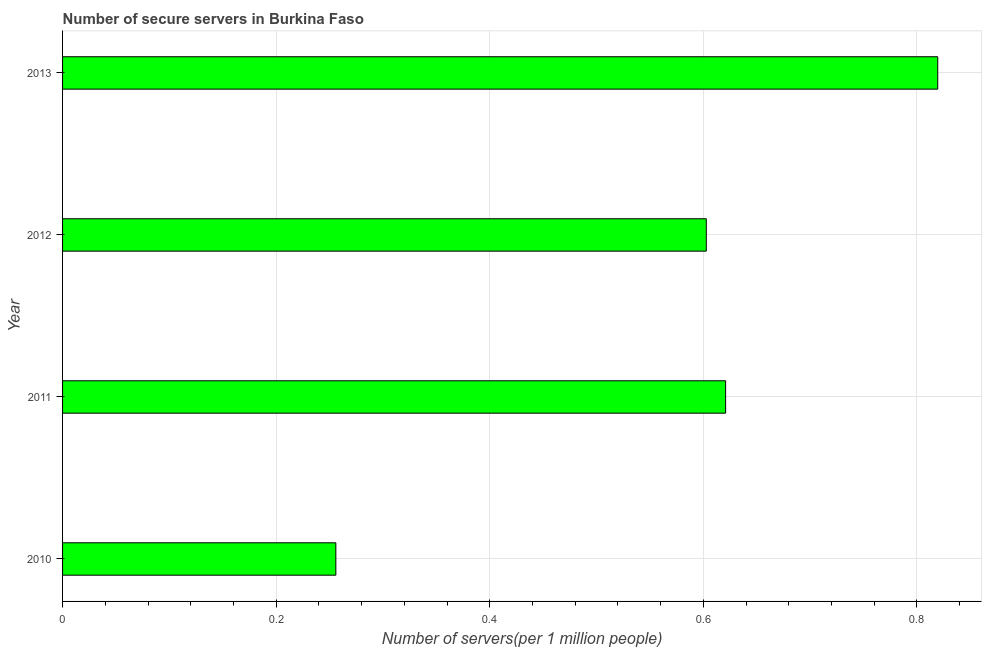Does the graph contain grids?
Give a very brief answer. Yes. What is the title of the graph?
Make the answer very short. Number of secure servers in Burkina Faso. What is the label or title of the X-axis?
Make the answer very short. Number of servers(per 1 million people). What is the label or title of the Y-axis?
Your answer should be compact. Year. What is the number of secure internet servers in 2013?
Your response must be concise. 0.82. Across all years, what is the maximum number of secure internet servers?
Offer a very short reply. 0.82. Across all years, what is the minimum number of secure internet servers?
Your answer should be compact. 0.26. What is the sum of the number of secure internet servers?
Provide a succinct answer. 2.3. What is the difference between the number of secure internet servers in 2010 and 2011?
Your response must be concise. -0.36. What is the average number of secure internet servers per year?
Offer a terse response. 0.57. What is the median number of secure internet servers?
Provide a short and direct response. 0.61. In how many years, is the number of secure internet servers greater than 0.28 ?
Ensure brevity in your answer.  3. Do a majority of the years between 2011 and 2012 (inclusive) have number of secure internet servers greater than 0.2 ?
Keep it short and to the point. Yes. What is the ratio of the number of secure internet servers in 2010 to that in 2012?
Give a very brief answer. 0.42. Is the number of secure internet servers in 2011 less than that in 2013?
Make the answer very short. Yes. Is the difference between the number of secure internet servers in 2010 and 2012 greater than the difference between any two years?
Ensure brevity in your answer.  No. What is the difference between the highest and the second highest number of secure internet servers?
Your answer should be compact. 0.2. Is the sum of the number of secure internet servers in 2011 and 2012 greater than the maximum number of secure internet servers across all years?
Your response must be concise. Yes. What is the difference between the highest and the lowest number of secure internet servers?
Ensure brevity in your answer.  0.56. Are all the bars in the graph horizontal?
Your response must be concise. Yes. How many years are there in the graph?
Provide a succinct answer. 4. What is the difference between two consecutive major ticks on the X-axis?
Make the answer very short. 0.2. Are the values on the major ticks of X-axis written in scientific E-notation?
Your answer should be very brief. No. What is the Number of servers(per 1 million people) of 2010?
Provide a succinct answer. 0.26. What is the Number of servers(per 1 million people) of 2011?
Your answer should be very brief. 0.62. What is the Number of servers(per 1 million people) in 2012?
Provide a succinct answer. 0.6. What is the Number of servers(per 1 million people) in 2013?
Your answer should be very brief. 0.82. What is the difference between the Number of servers(per 1 million people) in 2010 and 2011?
Offer a very short reply. -0.36. What is the difference between the Number of servers(per 1 million people) in 2010 and 2012?
Your answer should be compact. -0.35. What is the difference between the Number of servers(per 1 million people) in 2010 and 2013?
Your response must be concise. -0.56. What is the difference between the Number of servers(per 1 million people) in 2011 and 2012?
Ensure brevity in your answer.  0.02. What is the difference between the Number of servers(per 1 million people) in 2011 and 2013?
Your answer should be very brief. -0.2. What is the difference between the Number of servers(per 1 million people) in 2012 and 2013?
Ensure brevity in your answer.  -0.22. What is the ratio of the Number of servers(per 1 million people) in 2010 to that in 2011?
Offer a very short reply. 0.41. What is the ratio of the Number of servers(per 1 million people) in 2010 to that in 2012?
Make the answer very short. 0.42. What is the ratio of the Number of servers(per 1 million people) in 2010 to that in 2013?
Your answer should be compact. 0.31. What is the ratio of the Number of servers(per 1 million people) in 2011 to that in 2012?
Your response must be concise. 1.03. What is the ratio of the Number of servers(per 1 million people) in 2011 to that in 2013?
Make the answer very short. 0.76. What is the ratio of the Number of servers(per 1 million people) in 2012 to that in 2013?
Give a very brief answer. 0.74. 